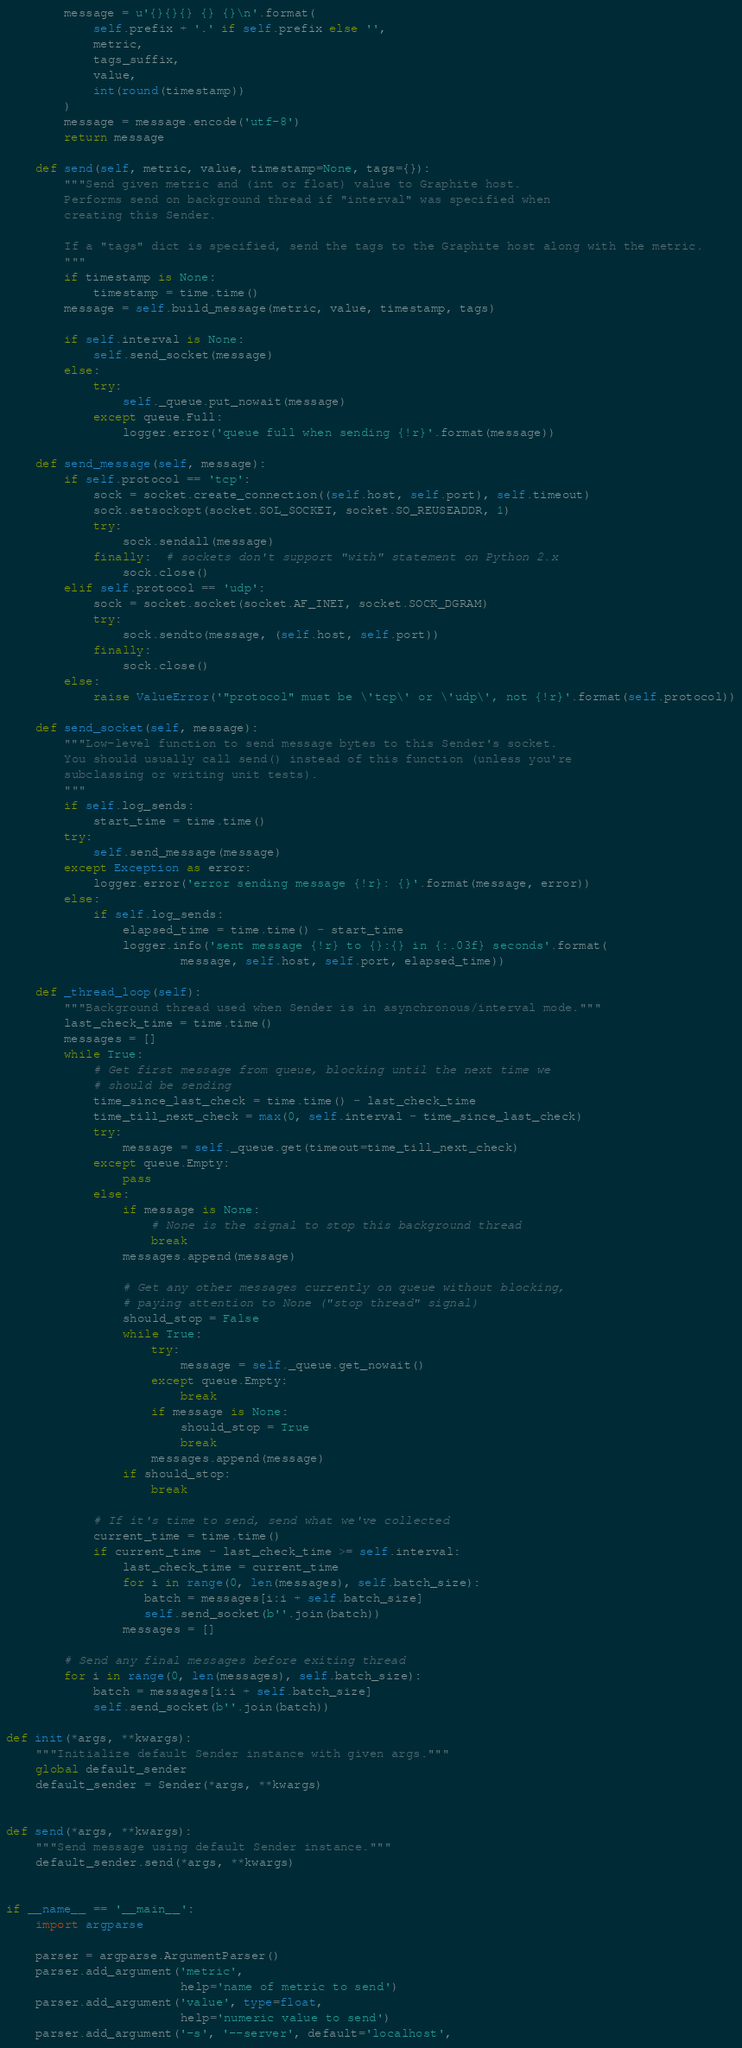Convert code to text. <code><loc_0><loc_0><loc_500><loc_500><_Python_>        message = u'{}{}{} {} {}\n'.format(
            self.prefix + '.' if self.prefix else '',
            metric,
            tags_suffix,
            value,
            int(round(timestamp))
        )
        message = message.encode('utf-8')
        return message

    def send(self, metric, value, timestamp=None, tags={}):
        """Send given metric and (int or float) value to Graphite host.
        Performs send on background thread if "interval" was specified when
        creating this Sender.

        If a "tags" dict is specified, send the tags to the Graphite host along with the metric.
        """
        if timestamp is None:
            timestamp = time.time()
        message = self.build_message(metric, value, timestamp, tags)

        if self.interval is None:
            self.send_socket(message)
        else:
            try:
                self._queue.put_nowait(message)
            except queue.Full:
                logger.error('queue full when sending {!r}'.format(message))

    def send_message(self, message):
        if self.protocol == 'tcp':
            sock = socket.create_connection((self.host, self.port), self.timeout)
            sock.setsockopt(socket.SOL_SOCKET, socket.SO_REUSEADDR, 1)
            try:
                sock.sendall(message)
            finally:  # sockets don't support "with" statement on Python 2.x
                sock.close()
        elif self.protocol == 'udp':
            sock = socket.socket(socket.AF_INET, socket.SOCK_DGRAM)
            try:
                sock.sendto(message, (self.host, self.port))
            finally:
                sock.close()
        else:
            raise ValueError('"protocol" must be \'tcp\' or \'udp\', not {!r}'.format(self.protocol))

    def send_socket(self, message):
        """Low-level function to send message bytes to this Sender's socket.
        You should usually call send() instead of this function (unless you're
        subclassing or writing unit tests).
        """
        if self.log_sends:
            start_time = time.time()
        try:
            self.send_message(message)
        except Exception as error:
            logger.error('error sending message {!r}: {}'.format(message, error))
        else:
            if self.log_sends:
                elapsed_time = time.time() - start_time
                logger.info('sent message {!r} to {}:{} in {:.03f} seconds'.format(
                        message, self.host, self.port, elapsed_time))

    def _thread_loop(self):
        """Background thread used when Sender is in asynchronous/interval mode."""
        last_check_time = time.time()
        messages = []
        while True:
            # Get first message from queue, blocking until the next time we
            # should be sending
            time_since_last_check = time.time() - last_check_time
            time_till_next_check = max(0, self.interval - time_since_last_check)
            try:
                message = self._queue.get(timeout=time_till_next_check)
            except queue.Empty:
                pass
            else:
                if message is None:
                    # None is the signal to stop this background thread
                    break
                messages.append(message)

                # Get any other messages currently on queue without blocking,
                # paying attention to None ("stop thread" signal)
                should_stop = False
                while True:
                    try:
                        message = self._queue.get_nowait()
                    except queue.Empty:
                        break
                    if message is None:
                        should_stop = True
                        break
                    messages.append(message)
                if should_stop:
                    break

            # If it's time to send, send what we've collected
            current_time = time.time()
            if current_time - last_check_time >= self.interval:
                last_check_time = current_time
                for i in range(0, len(messages), self.batch_size):
                   batch = messages[i:i + self.batch_size]
                   self.send_socket(b''.join(batch))
                messages = []

        # Send any final messages before exiting thread
        for i in range(0, len(messages), self.batch_size):
            batch = messages[i:i + self.batch_size]
            self.send_socket(b''.join(batch))

def init(*args, **kwargs):
    """Initialize default Sender instance with given args."""
    global default_sender
    default_sender = Sender(*args, **kwargs)


def send(*args, **kwargs):
    """Send message using default Sender instance."""
    default_sender.send(*args, **kwargs)


if __name__ == '__main__':
    import argparse

    parser = argparse.ArgumentParser()
    parser.add_argument('metric',
                        help='name of metric to send')
    parser.add_argument('value', type=float,
                        help='numeric value to send')
    parser.add_argument('-s', '--server', default='localhost',</code> 